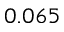Convert formula to latex. <formula><loc_0><loc_0><loc_500><loc_500>0 . 0 6 5</formula> 